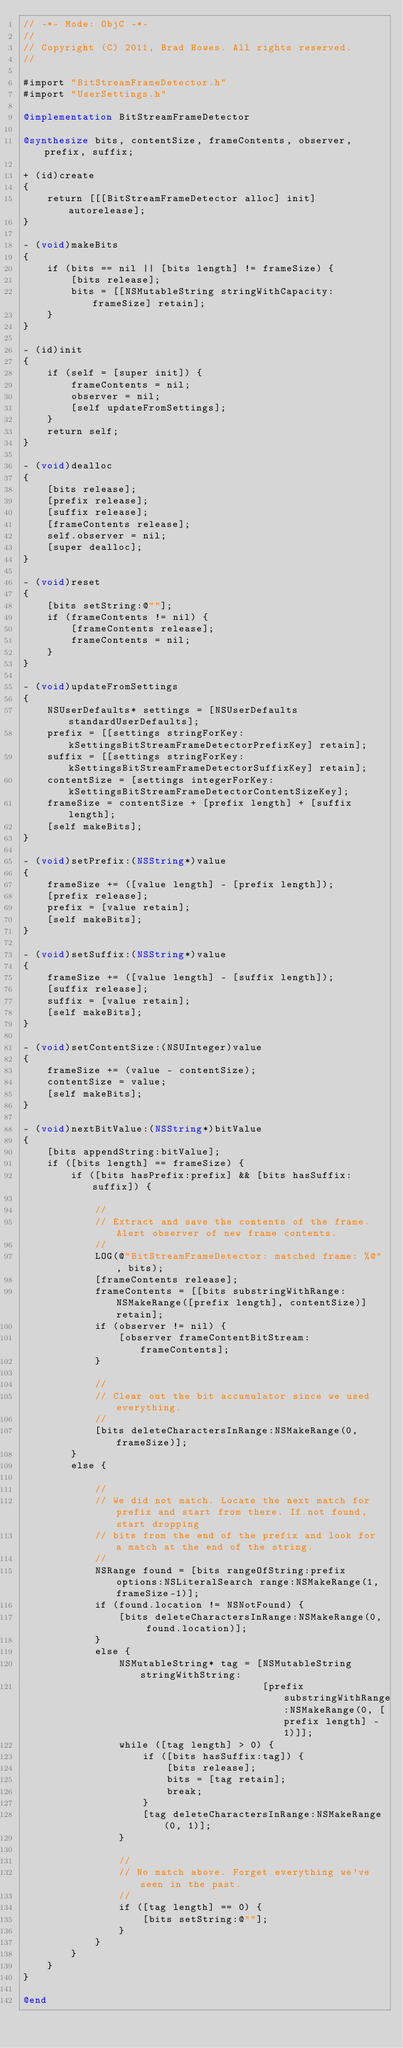Convert code to text. <code><loc_0><loc_0><loc_500><loc_500><_ObjectiveC_>// -*- Mode: ObjC -*-
//
// Copyright (C) 2011, Brad Howes. All rights reserved.
//

#import "BitStreamFrameDetector.h"
#import "UserSettings.h"

@implementation BitStreamFrameDetector

@synthesize bits, contentSize, frameContents, observer, prefix, suffix;

+ (id)create
{
    return [[[BitStreamFrameDetector alloc] init] autorelease];
}

- (void)makeBits
{
    if (bits == nil || [bits length] != frameSize) {
        [bits release];
        bits = [[NSMutableString stringWithCapacity:frameSize] retain];
    }
}

- (id)init
{
    if (self = [super init]) {
        frameContents = nil;
        observer = nil;
        [self updateFromSettings];
    }
    return self;
}

- (void)dealloc
{
    [bits release];
    [prefix release];
    [suffix release];
    [frameContents release];
    self.observer = nil;
    [super dealloc];
}

- (void)reset
{
    [bits setString:@""];
    if (frameContents != nil) {
        [frameContents release];
        frameContents = nil;
    }
}

- (void)updateFromSettings
{
    NSUserDefaults* settings = [NSUserDefaults standardUserDefaults];
    prefix = [[settings stringForKey:kSettingsBitStreamFrameDetectorPrefixKey] retain];
    suffix = [[settings stringForKey:kSettingsBitStreamFrameDetectorSuffixKey] retain];
    contentSize = [settings integerForKey:kSettingsBitStreamFrameDetectorContentSizeKey];
    frameSize = contentSize + [prefix length] + [suffix length];
    [self makeBits];
}

- (void)setPrefix:(NSString*)value
{
    frameSize += ([value length] - [prefix length]);
    [prefix release];
    prefix = [value retain];
    [self makeBits];
}

- (void)setSuffix:(NSString*)value
{
    frameSize += ([value length] - [suffix length]);
    [suffix release];
    suffix = [value retain];
    [self makeBits];
}

- (void)setContentSize:(NSUInteger)value
{
    frameSize += (value - contentSize);
    contentSize = value;
    [self makeBits];
}

- (void)nextBitValue:(NSString*)bitValue
{
    [bits appendString:bitValue];
    if ([bits length] == frameSize) {
        if ([bits hasPrefix:prefix] && [bits hasSuffix:suffix]) {
            
            //
            // Extract and save the contents of the frame. Alert observer of new frame contents.
            //
            LOG(@"BitStreamFrameDetector: matched frame: %@", bits);
            [frameContents release];
            frameContents = [[bits substringWithRange:NSMakeRange([prefix length], contentSize)] retain];
            if (observer != nil) {
                [observer frameContentBitStream:frameContents];
            }
            
            //
            // Clear out the bit accumulator since we used everything.
            //
            [bits deleteCharactersInRange:NSMakeRange(0, frameSize)];
        }
        else {
            
            //
            // We did not match. Locate the next match for prefix and start from there. If not found, start dropping
            // bits from the end of the prefix and look for a match at the end of the string.
            //
            NSRange found = [bits rangeOfString:prefix options:NSLiteralSearch range:NSMakeRange(1, frameSize-1)];
            if (found.location != NSNotFound) {
                [bits deleteCharactersInRange:NSMakeRange(0, found.location)];
            }
            else {
                NSMutableString* tag = [NSMutableString stringWithString:
                                        [prefix substringWithRange:NSMakeRange(0, [prefix length] - 1)]];
                while ([tag length] > 0) {
                    if ([bits hasSuffix:tag]) {
                        [bits release];
                        bits = [tag retain];
                        break;
                    }
                    [tag deleteCharactersInRange:NSMakeRange(0, 1)];
                }
                
                //
                // No match above. Forget everything we've seen in the past.
                //
                if ([tag length] == 0) {
                    [bits setString:@""];
                }
            }
        }
    }
}

@end
</code> 